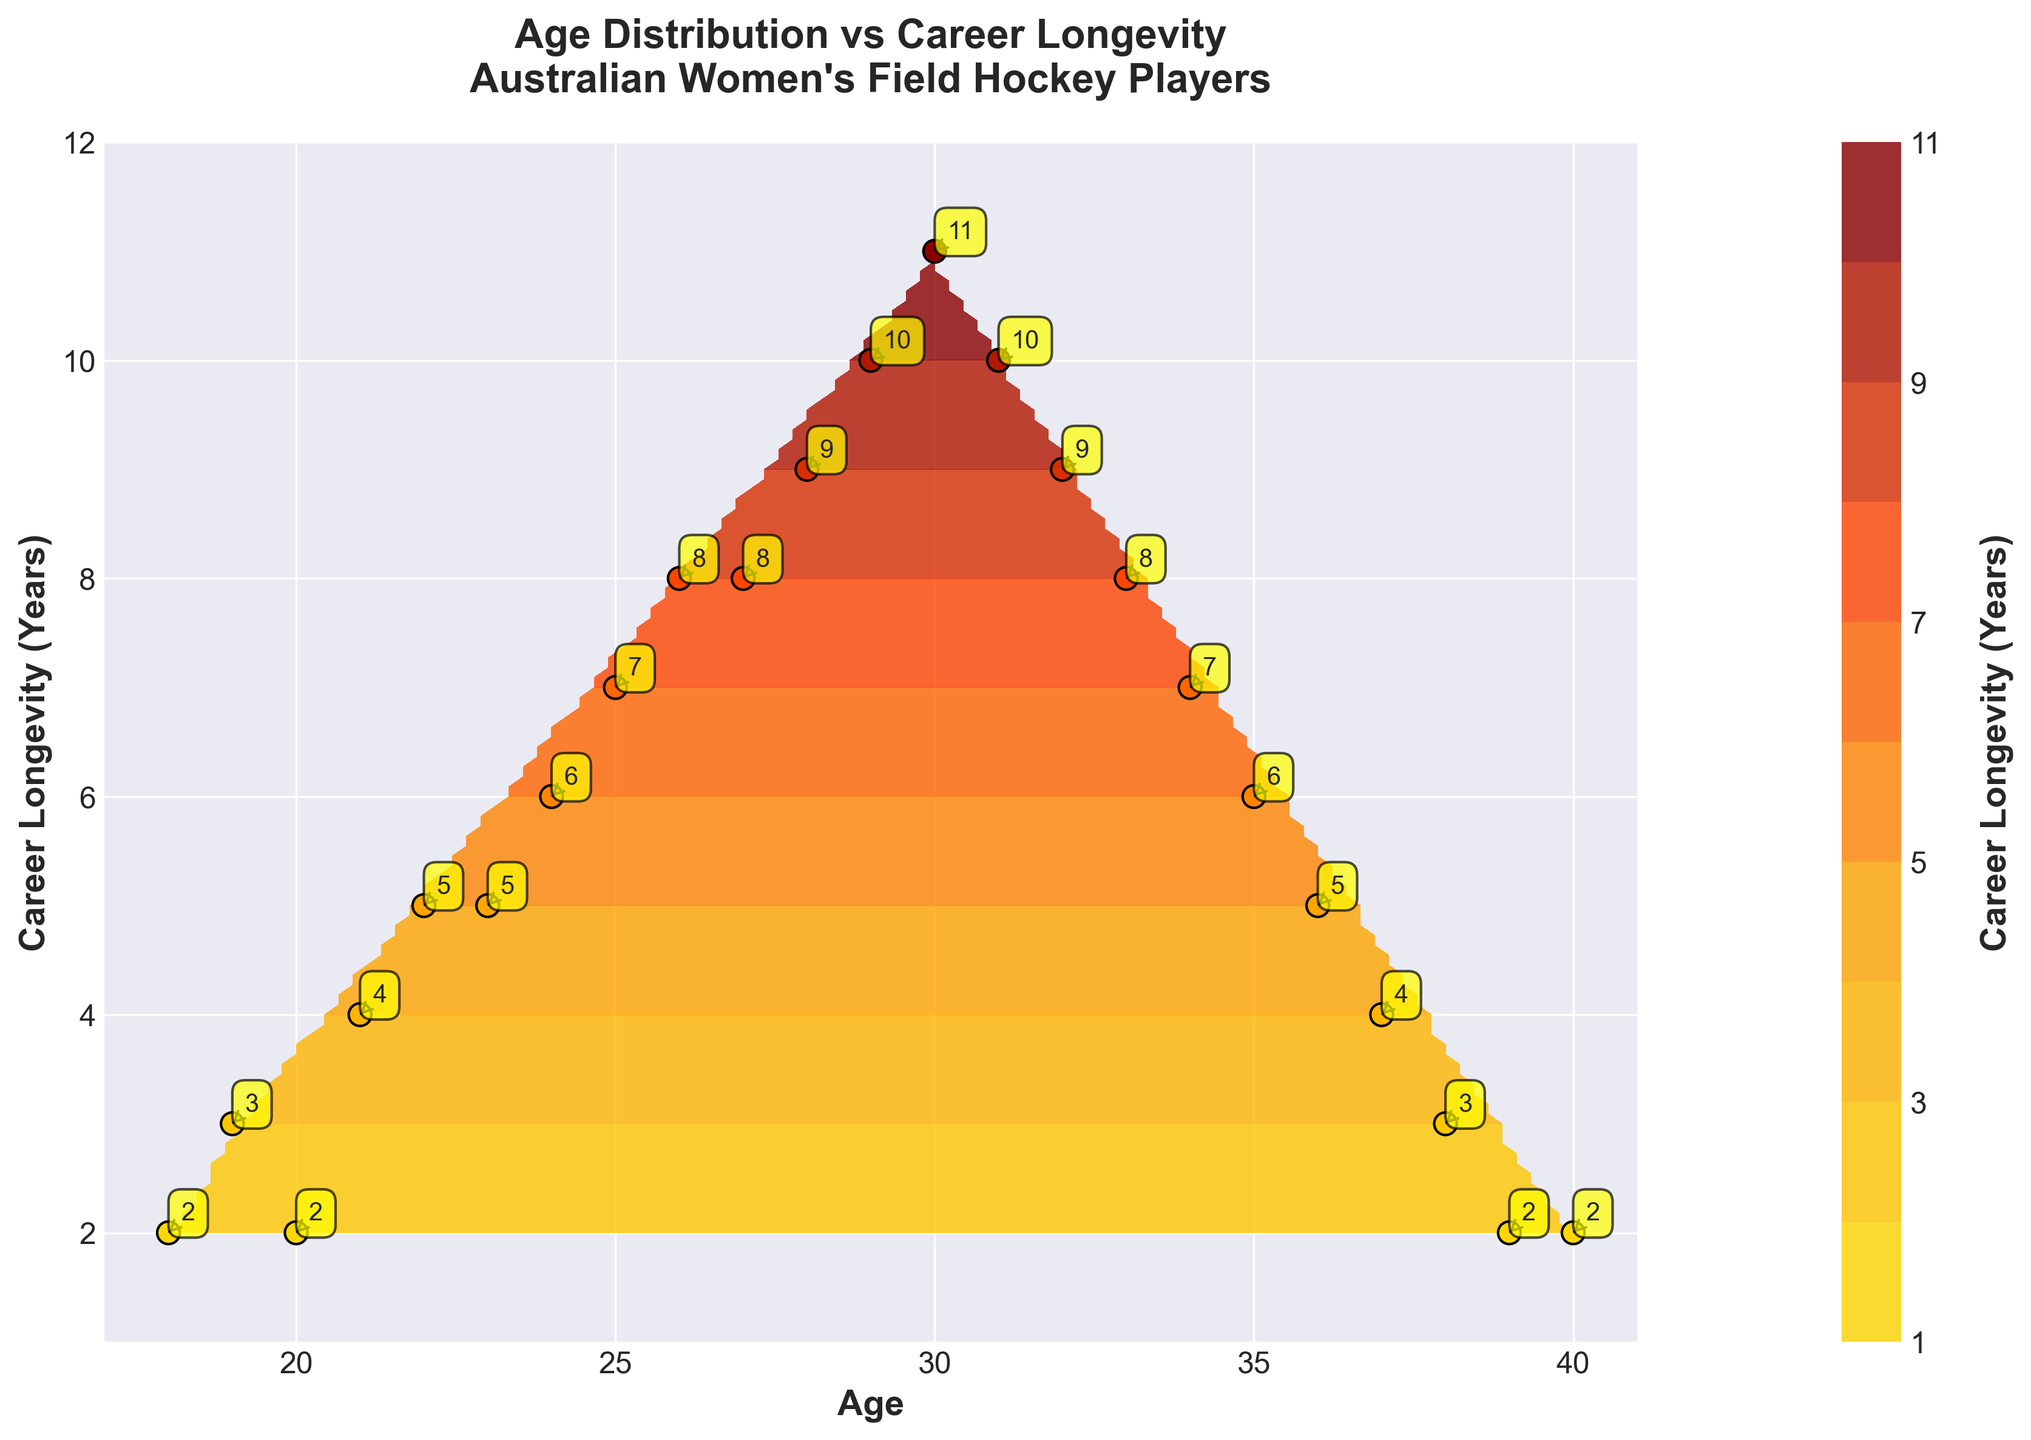What is the title of the figure? The title of the figure is written at the top. You can see "Age Distribution vs Career Longevity\nAustralian Women's Field Hockey Players" clearly.
Answer: Age Distribution vs Career Longevity\nAustralian Women's Field Hockey Players How many unique age points are plotted? By looking at the scatter points, we can count the distinct age values along the x-axis. Each age from 18 to 40 appears exactly once.
Answer: 23 What does the color gradient represent on the contour plot? The color gradient of the contour plot is depicted in the color bar which labels the Career Longevity in years. It uses shades from yellow to dark red to indicate shorter to longer career longevity.
Answer: Career Longevity (Years) Which age group has the longest career longevity? By observing the color and the annotations nearby points, the dark red and the value labeled near age 30 shows the longest career longevity of 11 years.
Answer: Age 30 At what age does career longevity peak and then start to decrease? By observing the trend of the contour and annotated values, the longevity peaks at age 30 (11 years) and then starts to decrease gradually.
Answer: Age 30 What can you infer about players above the age of 35? Observing the scatter points and contour lines, players above age 35 generally have shorter career longevity, which is marked by lighter colors and longevity values of 6 years or less.
Answer: Shorter career longevity How does career longevity change as the age of the player increases from 20 to 30? Starting from age 20 with a career longevity of 2 years, the figure shows an increasing trend, reaching the peak of 11 years at age 30, as represented by the contour colors.
Answer: Increases Around what age do players start experiencing a decline in career longevity? Career longevity starts declining after the age of 30, with decreasing values for ages above 30 as represented by cooler contour colors.
Answer: Around age 31 Is there any point where career longevity remains constant for consecutive years, and if so, where? From the scatter points and their annotated values, there is a period from age 28 to 29 where longevity is constant at 10 years.
Answer: Ages 28 to 29 